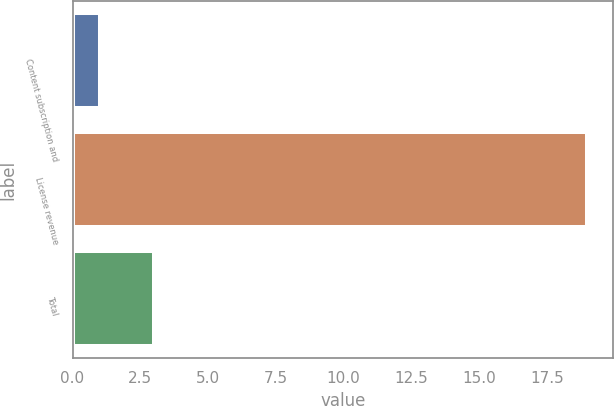Convert chart. <chart><loc_0><loc_0><loc_500><loc_500><bar_chart><fcel>Content subscription and<fcel>License revenue<fcel>Total<nl><fcel>1<fcel>19<fcel>3<nl></chart> 